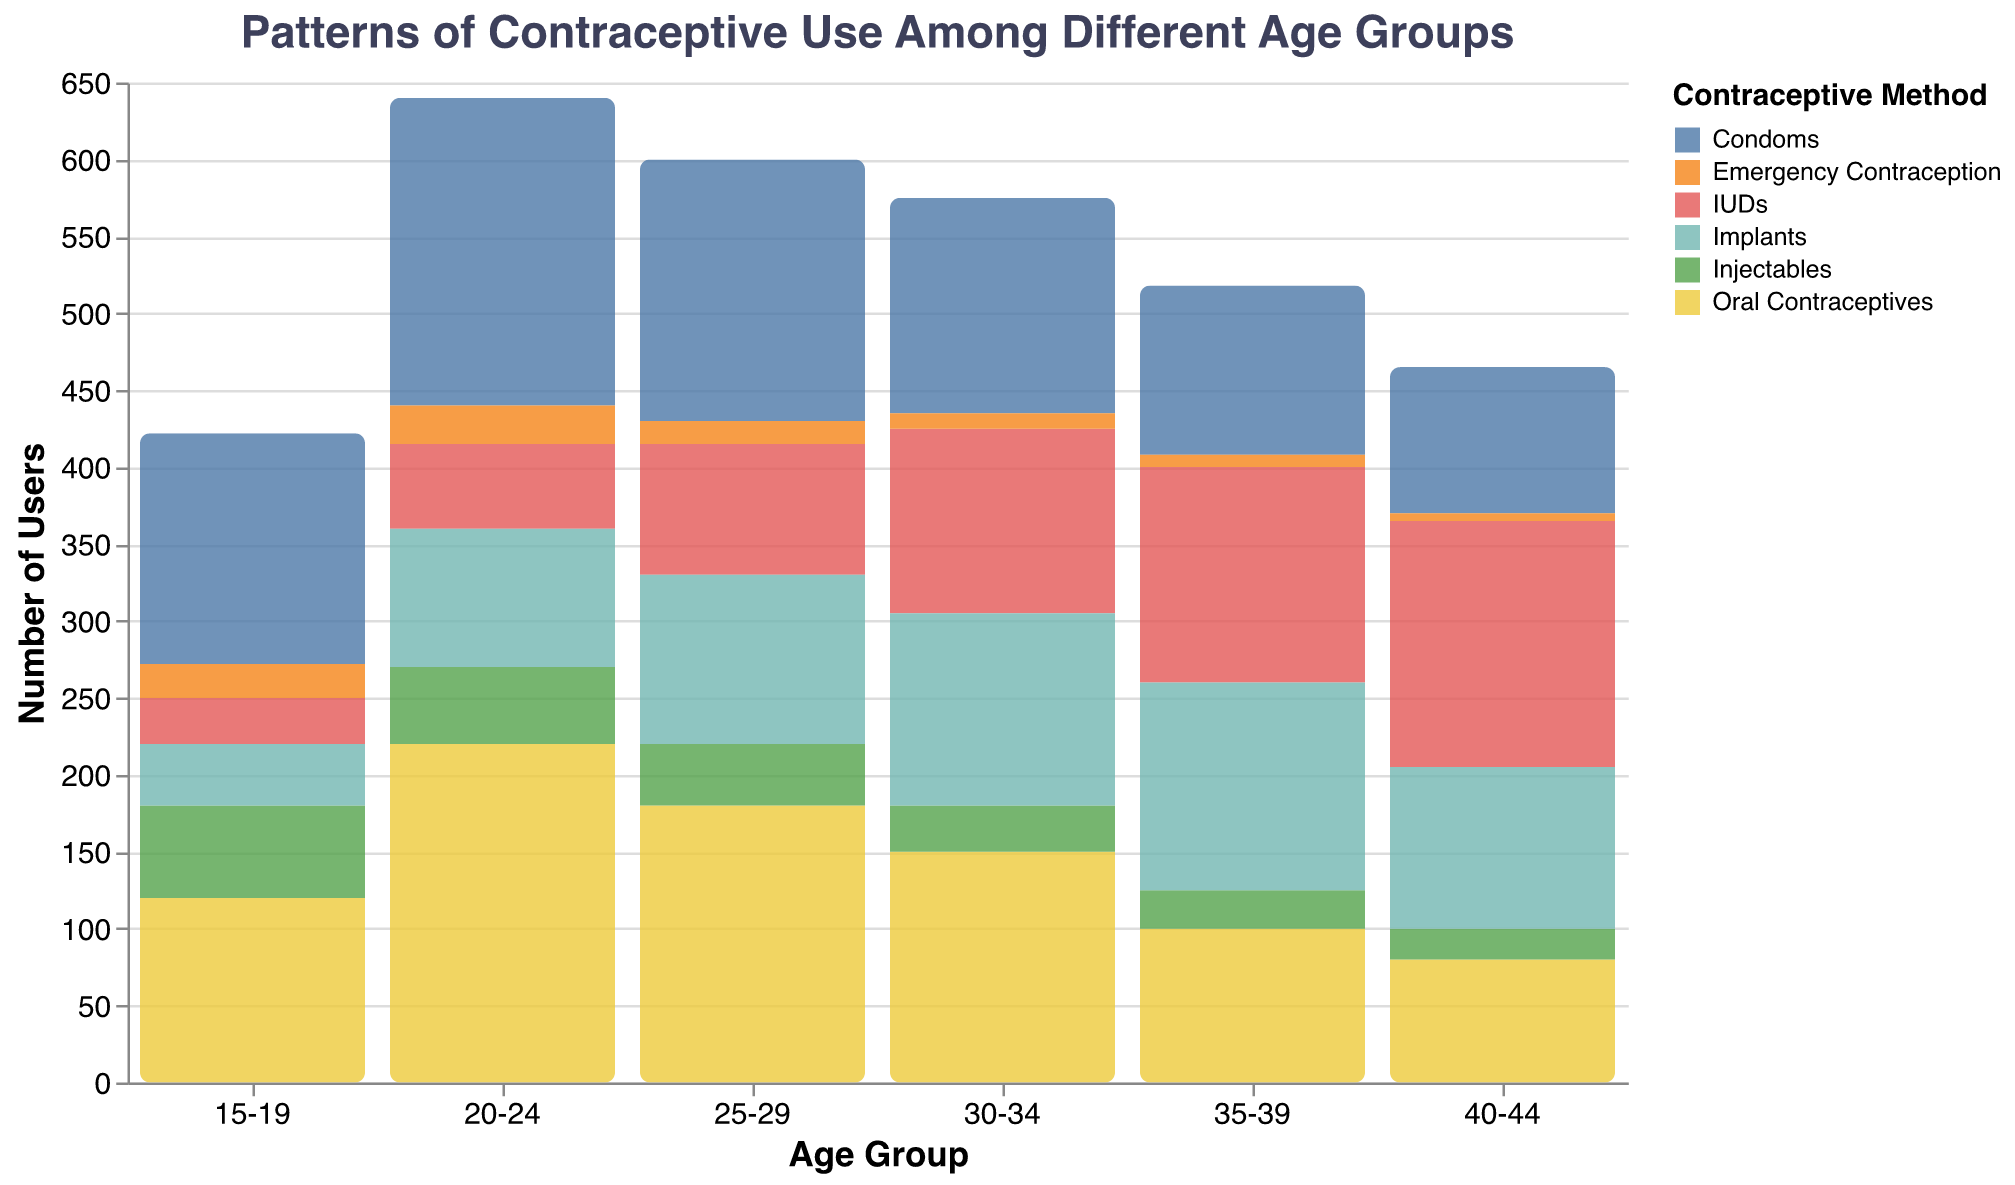What is the title of the figure? The title is located at the top of the figure and provides an overview of what the chart represents.
Answer: Patterns of Contraceptive Use Among Different Age Groups Which age group has the highest count of users for Oral Contraceptives? Check the bars corresponding to Oral Contraceptives and identify the age group with the highest bar.
Answer: 20-24 What is the total number of users for IUDs in the 30-34 age group? Locate the bar for IUDs in the 30-34 age group and read off its count.
Answer: 120 Among the 40-44 age group, which contraceptive method has the lowest count of users? Identify the bar with the lowest height for the 40-44 age group.
Answer: Emergency Contraception How many more users employ Condoms than Implants in the 20-24 age group? Find the counts for Condoms and Implants in the 20-24 age group, then subtract the count of Implants from the count of Condoms (200 - 90).
Answer: 110 Which contraceptive method shows an increasing trend across age groups? Look at the bars for each contraceptive method and identify which one generally increases from 15-19 to 40-44.
Answer: IUDs Calculate the average number of Emergency Contraception users across all age groups. Add the counts of Emergency Contraception users from all age groups and divide by the number of age groups (22 + 25 + 15 + 10 + 8 + 5) / 6.
Answer: 14.17 Which contraceptive method is most used by the 25-29 age group? Find the contraceptive method with the tallest bar in the 25-29 age group.
Answer: Oral Contraceptives How does the number of Injectables users in the 15-19 age group compare to the number in the 40-44 age group? Compare the count of Injectables users in 15-19 (60) to the count in 40-44 (20).
Answer: More in 15-19 What trend can be observed with Emergency Contraception use as age increases? Observe the heights of the bars for Emergency Contraception from 15-19 to 40-44.
Answer: Decreases with age 